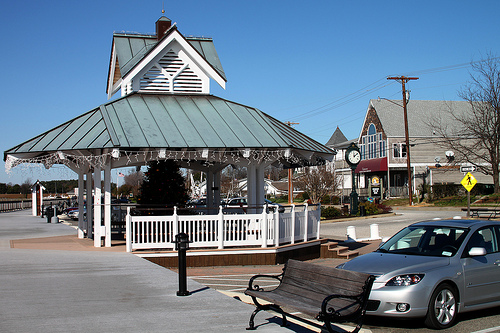Please provide the bounding box coordinate of the region this sentence describes: American flag on a pole. The bounding box coordinates for the region with the American flag on a pole are approximately [0.23, 0.5, 0.25, 0.57]. These coordinates encapsulate the specific region in the image where the American flag is located. 